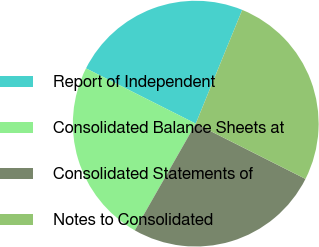<chart> <loc_0><loc_0><loc_500><loc_500><pie_chart><fcel>Report of Independent<fcel>Consolidated Balance Sheets at<fcel>Consolidated Statements of<fcel>Notes to Consolidated<nl><fcel>23.75%<fcel>24.17%<fcel>25.83%<fcel>26.25%<nl></chart> 